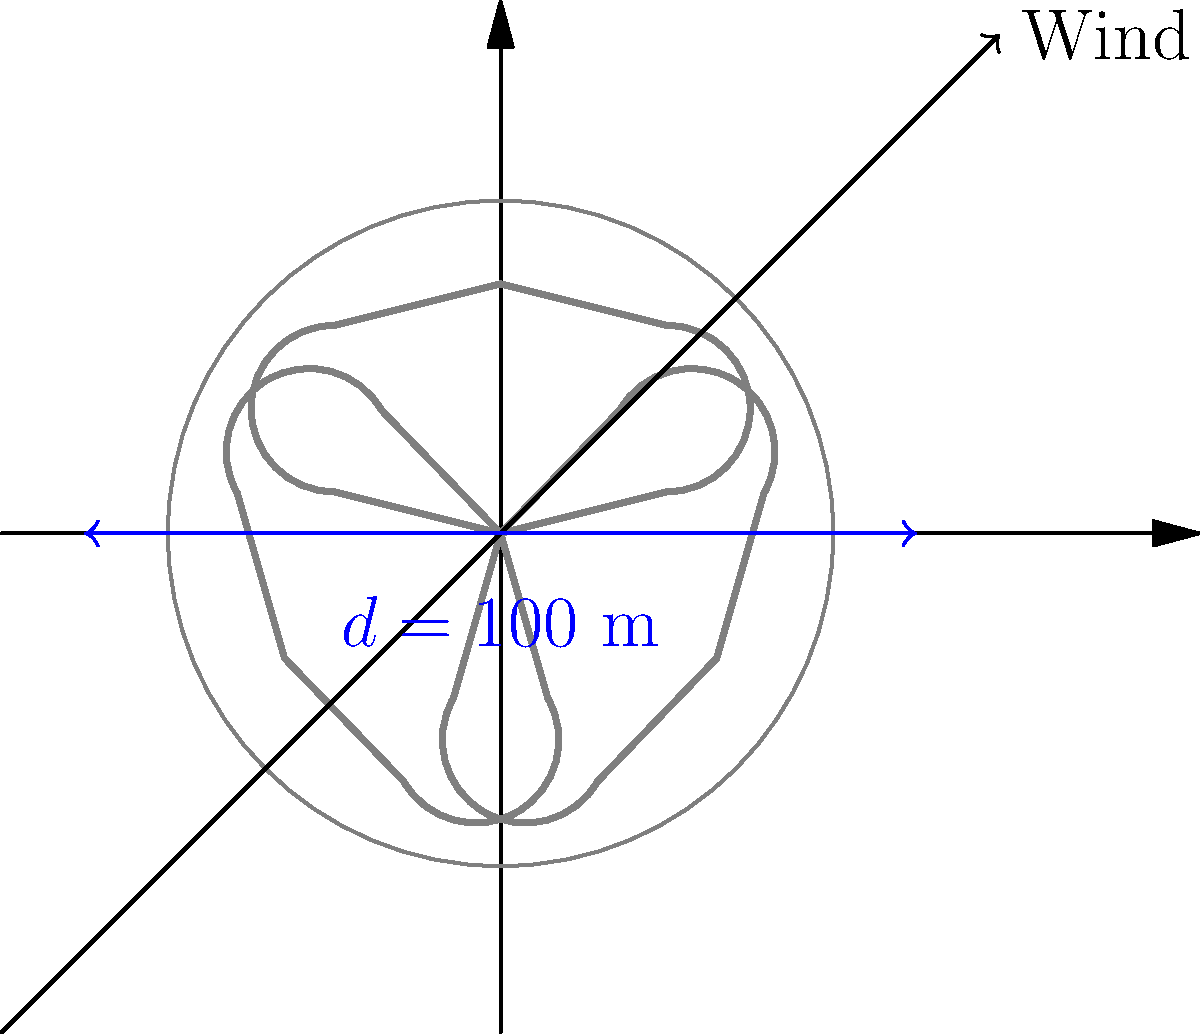Carrie Underwood's latest concert features a unique wind turbine with guitar-shaped blades as a stage prop. The turbine has a diameter of 100 m and operates in winds of 15 m/s. If the air density is 1.225 kg/m³ and the turbine has a power coefficient of 0.4, calculate the power output in megawatts (MW). Assume the turbine is operating at maximum efficiency. Let's approach this step-by-step, using the wind turbine power equation:

1) The wind turbine power equation is:
   $$P = \frac{1}{2} \rho A v^3 C_p$$

   Where:
   $P$ = Power output (W)
   $\rho$ = Air density (kg/m³)
   $A$ = Swept area (m²)
   $v$ = Wind speed (m/s)
   $C_p$ = Power coefficient

2) We're given:
   $\rho = 1.225$ kg/m³
   $d = 100$ m (diameter)
   $v = 15$ m/s
   $C_p = 0.4$

3) Calculate the swept area $A$:
   $$A = \pi r^2 = \pi (\frac{d}{2})^2 = \pi (50)^2 = 7,853.98$ m²

4) Now, let's substitute all values into the power equation:
   $$P = \frac{1}{2} (1.225)(7,853.98)(15^3)(0.4)$$

5) Calculate:
   $$P = 0.6125 \times 7,853.98 \times 3,375 \times 0.4$$
   $$P = 6,486,821.25$ W

6) Convert to megawatts:
   $$P = 6.49$ MW

Therefore, the power output of Carrie's guitar-blade wind turbine is approximately 6.49 MW.
Answer: 6.49 MW 